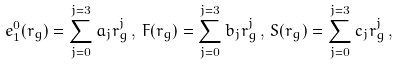<formula> <loc_0><loc_0><loc_500><loc_500>e _ { 1 } ^ { 0 } ( r _ { g } ) = \sum _ { j = 0 } ^ { j = 3 } a _ { j } r _ { g } ^ { j } \, , \, F ( r _ { g } ) = \sum _ { j = 0 } ^ { j = 3 } b _ { j } r _ { g } ^ { j } \, , \, S ( r _ { g } ) = \sum _ { j = 0 } ^ { j = 3 } c _ { j } r _ { g } ^ { j } \, ,</formula> 